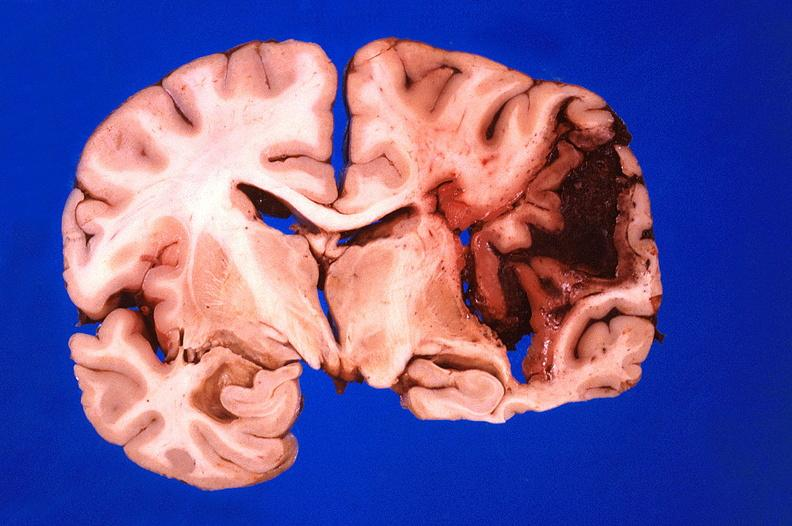does this image show brain, hematoma due to ruptured aneurysm?
Answer the question using a single word or phrase. Yes 